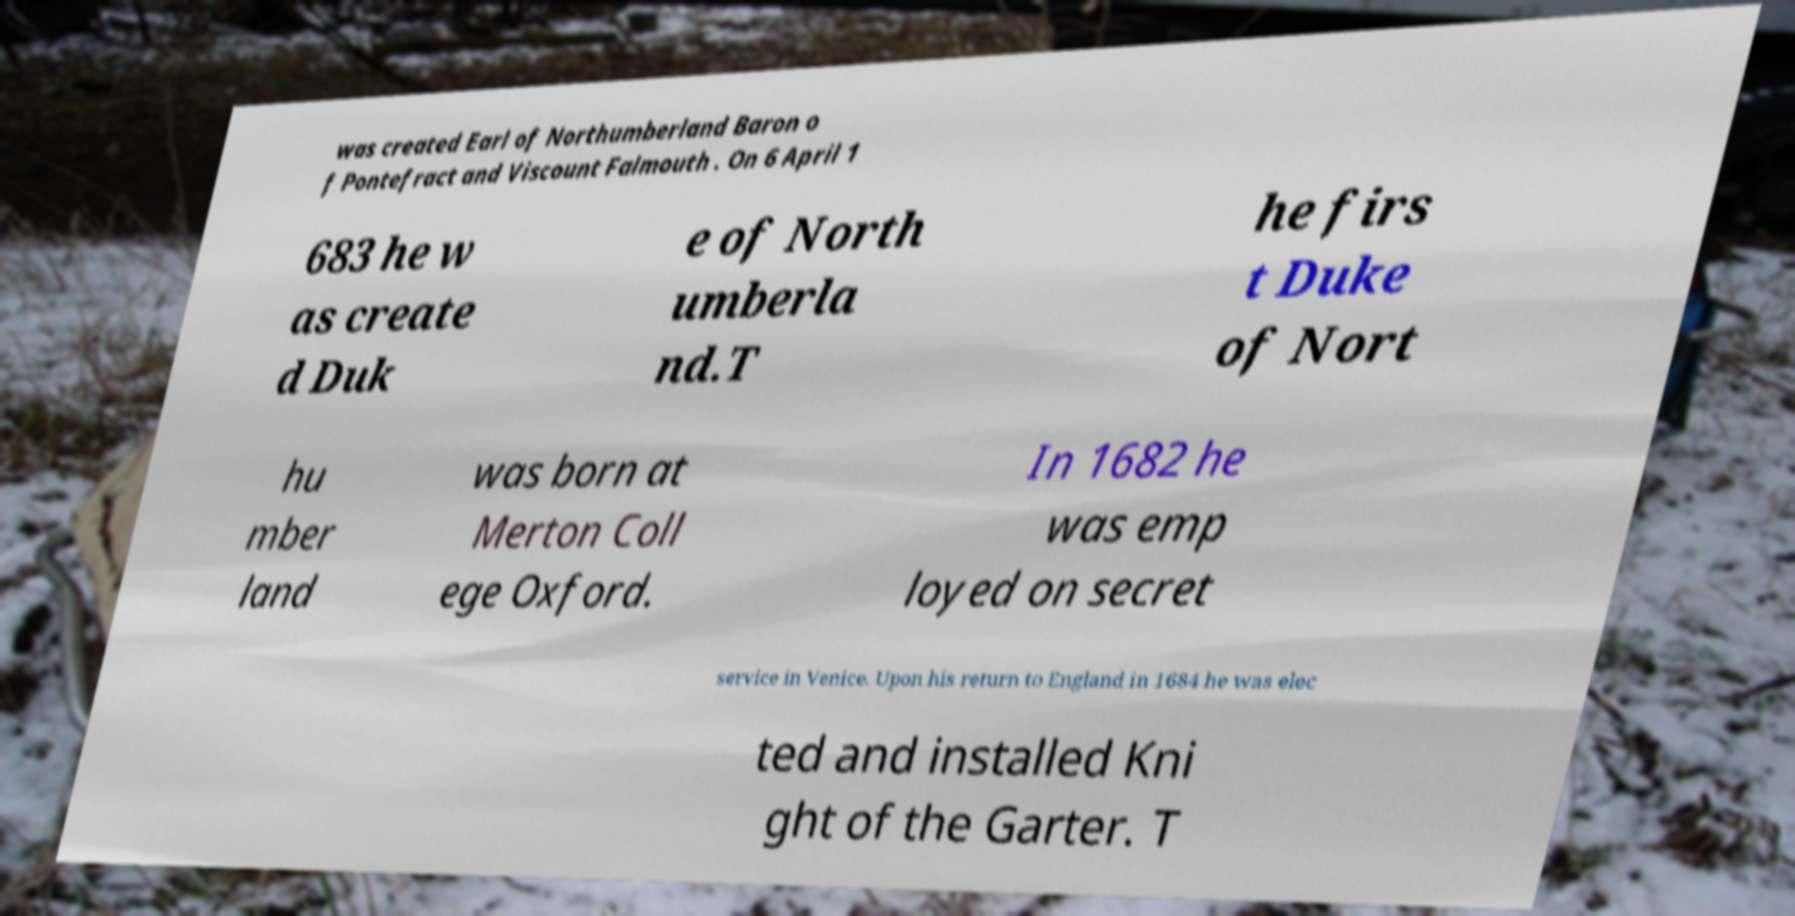Please read and relay the text visible in this image. What does it say? was created Earl of Northumberland Baron o f Pontefract and Viscount Falmouth . On 6 April 1 683 he w as create d Duk e of North umberla nd.T he firs t Duke of Nort hu mber land was born at Merton Coll ege Oxford. In 1682 he was emp loyed on secret service in Venice. Upon his return to England in 1684 he was elec ted and installed Kni ght of the Garter. T 